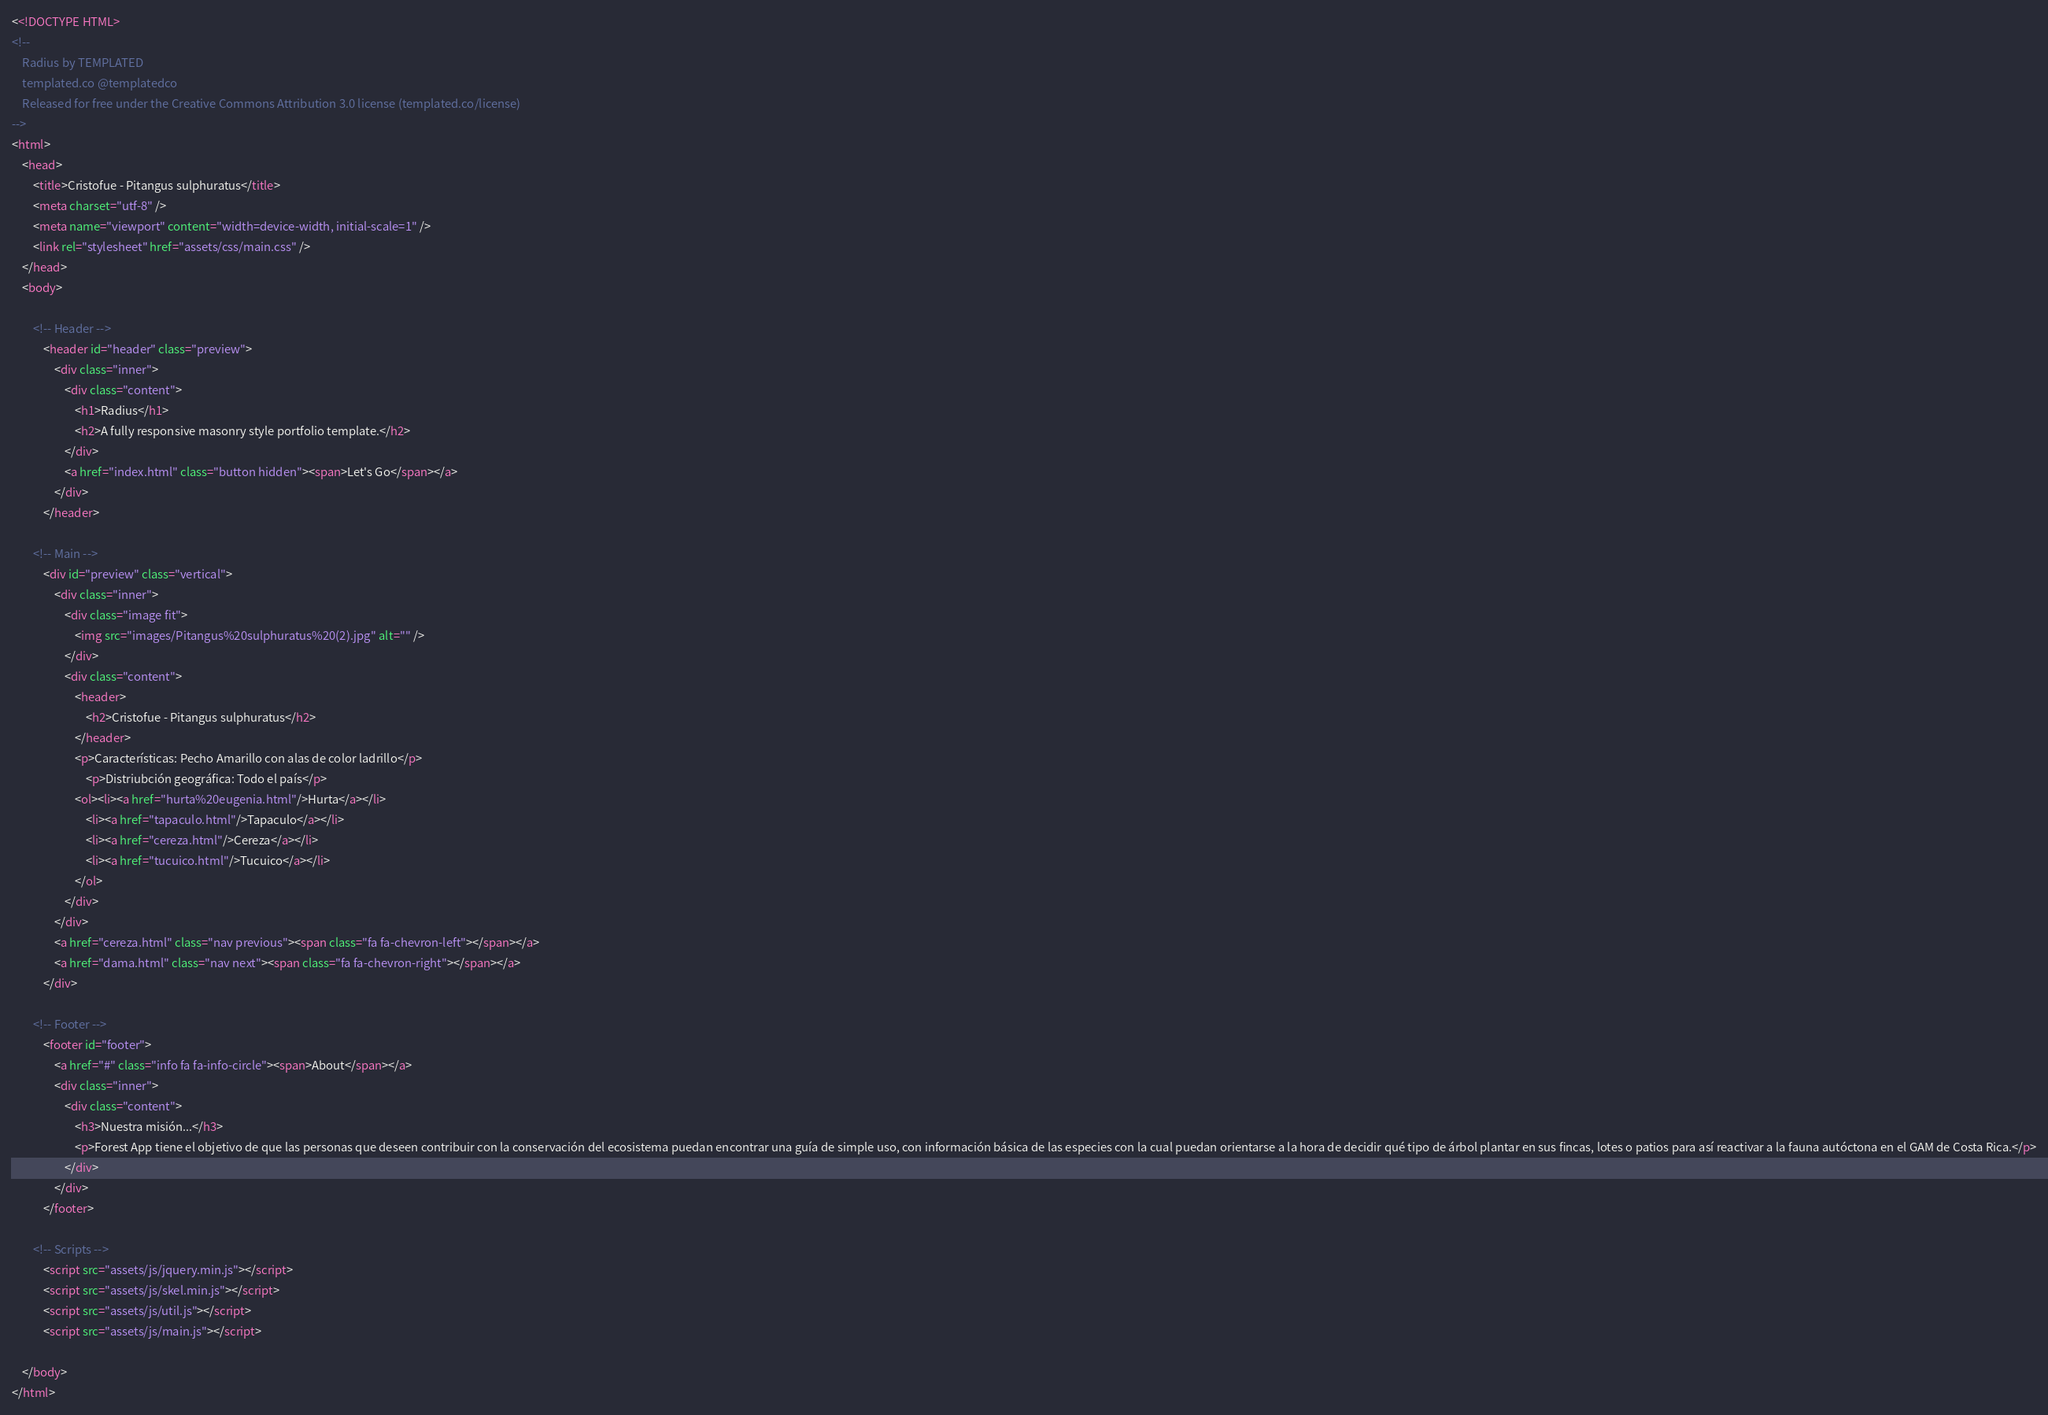<code> <loc_0><loc_0><loc_500><loc_500><_HTML_><<!DOCTYPE HTML>
<!--
	Radius by TEMPLATED
	templated.co @templatedco
	Released for free under the Creative Commons Attribution 3.0 license (templated.co/license)
-->
<html>
	<head>
		<title>Cristofue - Pitangus sulphuratus</title>
		<meta charset="utf-8" />
		<meta name="viewport" content="width=device-width, initial-scale=1" />
		<link rel="stylesheet" href="assets/css/main.css" />
	</head>
	<body>

		<!-- Header -->
			<header id="header" class="preview">
				<div class="inner">
					<div class="content">
						<h1>Radius</h1>
						<h2>A fully responsive masonry style portfolio template.</h2>
					</div>
					<a href="index.html" class="button hidden"><span>Let's Go</span></a>
				</div>
			</header>

		<!-- Main -->
			<div id="preview" class="vertical">
				<div class="inner">
					<div class="image fit">
						<img src="images/Pitangus%20sulphuratus%20(2).jpg" alt="" />
					</div>
					<div class="content">
						<header>
							<h2>Cristofue - Pitangus sulphuratus</h2>
						</header>
						<p>Características: Pecho Amarillo con alas de color ladrillo</p>
                            <p>Distriubción geográfica: Todo el país</p>
                        <ol><li><a href="hurta%20eugenia.html"/>Hurta</a></li>
                            <li><a href="tapaculo.html"/>Tapaculo</a></li>
                            <li><a href="cereza.html"/>Cereza</a></li>
                            <li><a href="tucuico.html"/>Tucuico</a></li>
                        </ol>
					</div>
				</div>
				<a href="cereza.html" class="nav previous"><span class="fa fa-chevron-left"></span></a>
				<a href="dama.html" class="nav next"><span class="fa fa-chevron-right"></span></a>
			</div>

		<!-- Footer -->
			<footer id="footer">
				<a href="#" class="info fa fa-info-circle"><span>About</span></a>
				<div class="inner">
					<div class="content">
						<h3>Nuestra misión...</h3>
						<p>Forest App tiene el objetivo de que las personas que deseen contribuir con la conservación del ecosistema puedan encontrar una guía de simple uso, con información básica de las especies con la cual puedan orientarse a la hora de decidir qué tipo de árbol plantar en sus fincas, lotes o patios para así reactivar a la fauna autóctona en el GAM de Costa Rica.</p>
                    </div>
				</div>
			</footer>

		<!-- Scripts -->
			<script src="assets/js/jquery.min.js"></script>
			<script src="assets/js/skel.min.js"></script>
			<script src="assets/js/util.js"></script>
			<script src="assets/js/main.js"></script>

	</body>
</html></code> 